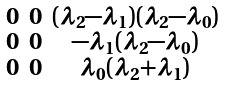<formula> <loc_0><loc_0><loc_500><loc_500>\begin{smallmatrix} 0 & 0 & ( \lambda _ { 2 } - \lambda _ { 1 } ) ( \lambda _ { 2 } - \lambda _ { 0 } ) \\ 0 & 0 & - \lambda _ { 1 } ( \lambda _ { 2 } - \lambda _ { 0 } ) \\ 0 & 0 & \lambda _ { 0 } ( \lambda _ { 2 } + \lambda _ { 1 } ) \\ \end{smallmatrix}</formula> 